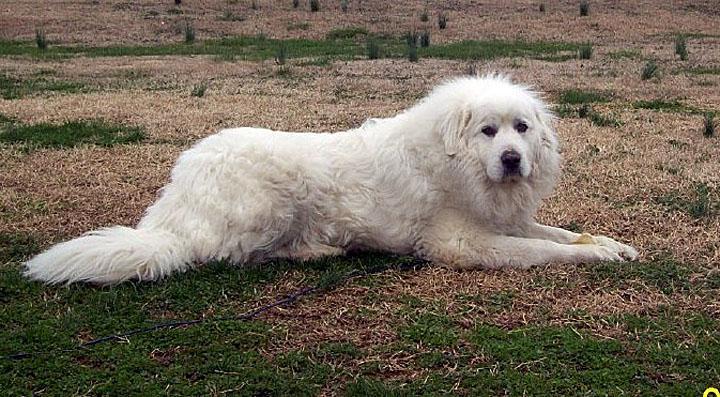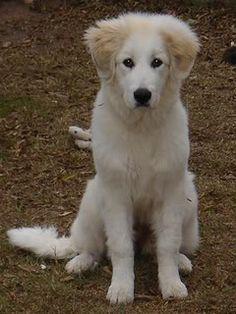The first image is the image on the left, the second image is the image on the right. For the images shown, is this caption "One dog is laying in the dirt." true? Answer yes or no. Yes. The first image is the image on the left, the second image is the image on the right. Given the left and right images, does the statement "There is a large dog with a child in one image, and a similar dog with it's mouth open in the other." hold true? Answer yes or no. No. 